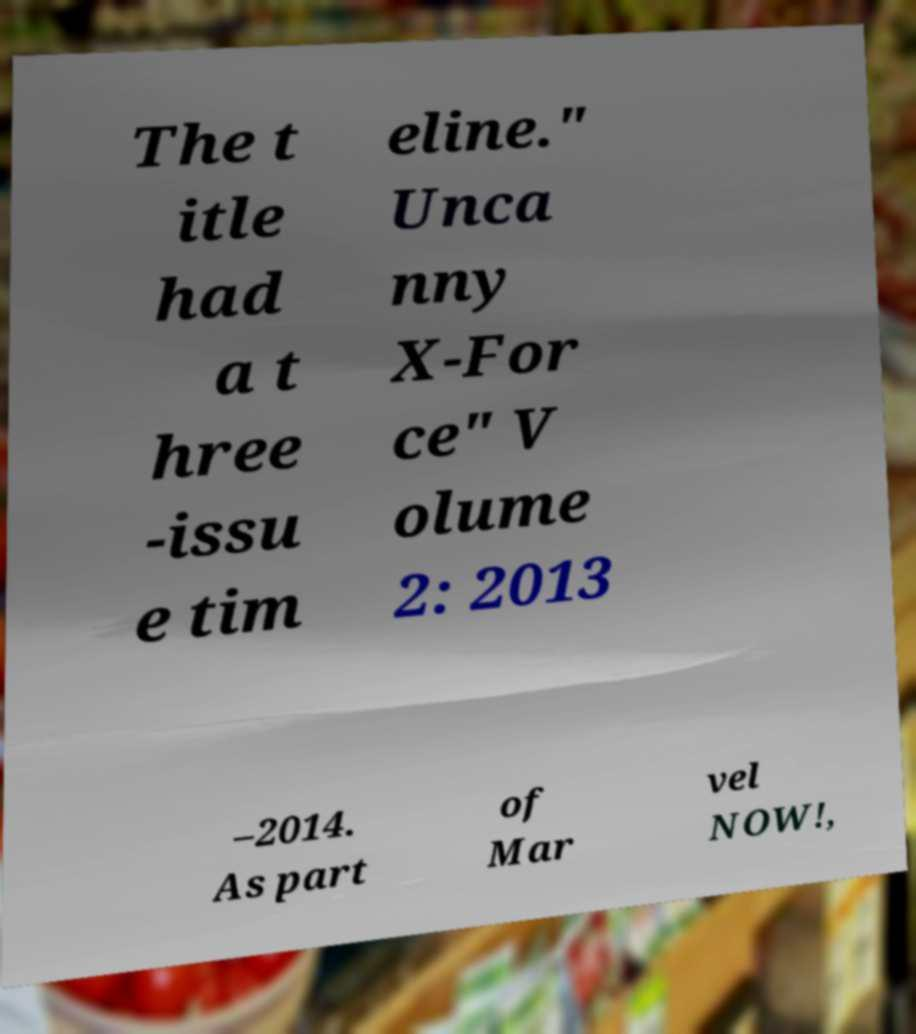Please read and relay the text visible in this image. What does it say? The t itle had a t hree -issu e tim eline." Unca nny X-For ce" V olume 2: 2013 –2014. As part of Mar vel NOW!, 